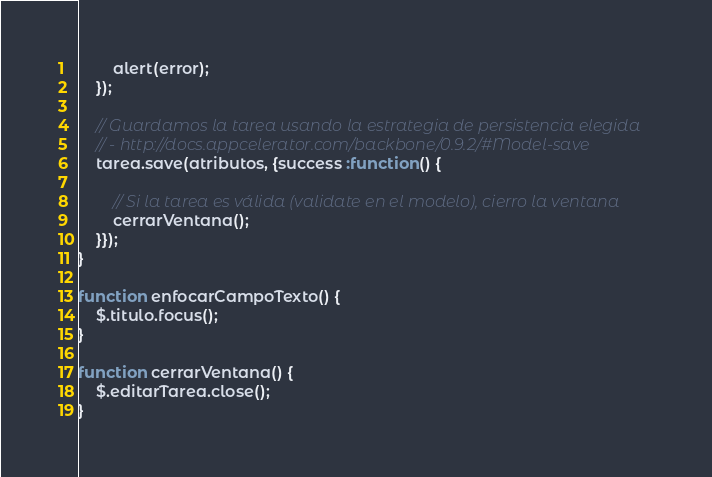Convert code to text. <code><loc_0><loc_0><loc_500><loc_500><_JavaScript_>		alert(error);
	});

	// Guardamos la tarea usando la estrategia de persistencia elegida
	// - http://docs.appcelerator.com/backbone/0.9.2/#Model-save
	tarea.save(atributos, {success :function() {
		
		// Si la tarea es válida (validate en el modelo), cierro la ventana
		cerrarVentana();
	}});
}

function enfocarCampoTexto() {
    $.titulo.focus();
}

function cerrarVentana() {
	$.editarTarea.close();
}</code> 